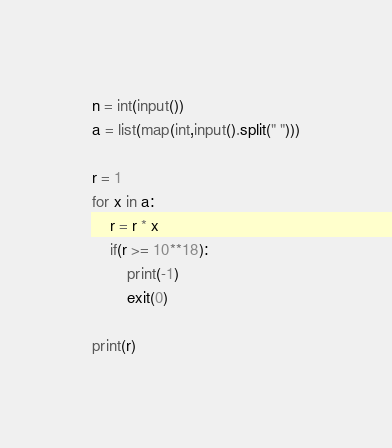Convert code to text. <code><loc_0><loc_0><loc_500><loc_500><_Python_>n = int(input())
a = list(map(int,input().split(" ")))

r = 1
for x in a:
    r = r * x
    if(r >= 10**18):
        print(-1)
        exit(0)

print(r)        
</code> 